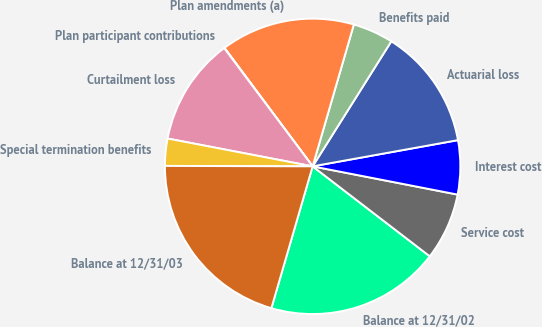Convert chart. <chart><loc_0><loc_0><loc_500><loc_500><pie_chart><fcel>Balance at 12/31/02<fcel>Service cost<fcel>Interest cost<fcel>Actuarial loss<fcel>Benefits paid<fcel>Plan amendments (a)<fcel>Plan participant contributions<fcel>Curtailment loss<fcel>Special termination benefits<fcel>Balance at 12/31/03<nl><fcel>19.08%<fcel>7.36%<fcel>5.9%<fcel>13.22%<fcel>4.44%<fcel>14.68%<fcel>0.04%<fcel>11.76%<fcel>2.97%<fcel>20.54%<nl></chart> 